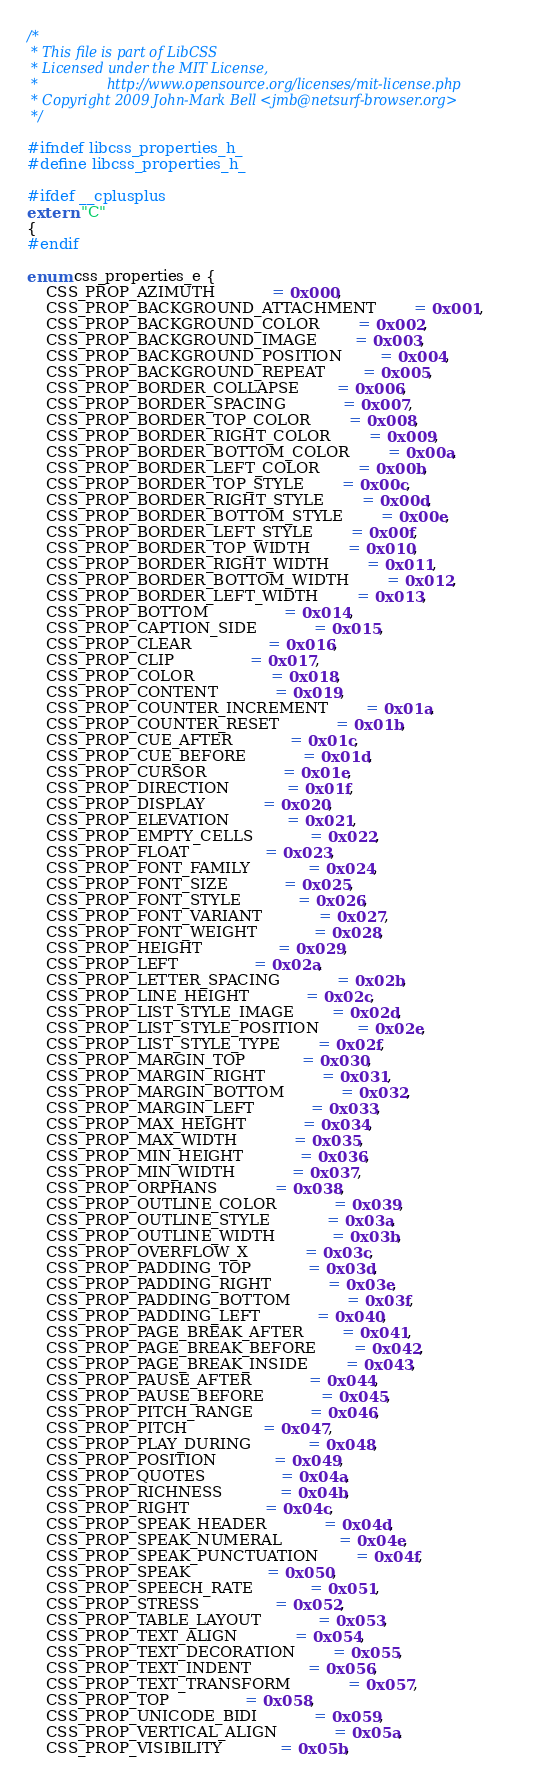Convert code to text. <code><loc_0><loc_0><loc_500><loc_500><_C_>/*
 * This file is part of LibCSS
 * Licensed under the MIT License,
 *                http://www.opensource.org/licenses/mit-license.php
 * Copyright 2009 John-Mark Bell <jmb@netsurf-browser.org>
 */

#ifndef libcss_properties_h_
#define libcss_properties_h_

#ifdef __cplusplus
extern "C"
{
#endif

enum css_properties_e {
	CSS_PROP_AZIMUTH			= 0x000,
	CSS_PROP_BACKGROUND_ATTACHMENT		= 0x001,
	CSS_PROP_BACKGROUND_COLOR		= 0x002,
	CSS_PROP_BACKGROUND_IMAGE		= 0x003,
	CSS_PROP_BACKGROUND_POSITION		= 0x004,
	CSS_PROP_BACKGROUND_REPEAT		= 0x005,
	CSS_PROP_BORDER_COLLAPSE		= 0x006,
	CSS_PROP_BORDER_SPACING			= 0x007,
	CSS_PROP_BORDER_TOP_COLOR		= 0x008,
	CSS_PROP_BORDER_RIGHT_COLOR		= 0x009,
	CSS_PROP_BORDER_BOTTOM_COLOR		= 0x00a,
	CSS_PROP_BORDER_LEFT_COLOR		= 0x00b,
	CSS_PROP_BORDER_TOP_STYLE		= 0x00c,
	CSS_PROP_BORDER_RIGHT_STYLE		= 0x00d,
	CSS_PROP_BORDER_BOTTOM_STYLE		= 0x00e,
	CSS_PROP_BORDER_LEFT_STYLE		= 0x00f,
	CSS_PROP_BORDER_TOP_WIDTH		= 0x010,
	CSS_PROP_BORDER_RIGHT_WIDTH		= 0x011,
	CSS_PROP_BORDER_BOTTOM_WIDTH		= 0x012,
	CSS_PROP_BORDER_LEFT_WIDTH		= 0x013,
	CSS_PROP_BOTTOM				= 0x014,
	CSS_PROP_CAPTION_SIDE			= 0x015,
	CSS_PROP_CLEAR				= 0x016,
	CSS_PROP_CLIP				= 0x017,
	CSS_PROP_COLOR				= 0x018,
	CSS_PROP_CONTENT			= 0x019,
	CSS_PROP_COUNTER_INCREMENT		= 0x01a,
	CSS_PROP_COUNTER_RESET			= 0x01b,
	CSS_PROP_CUE_AFTER			= 0x01c,
	CSS_PROP_CUE_BEFORE			= 0x01d,
	CSS_PROP_CURSOR				= 0x01e,
	CSS_PROP_DIRECTION			= 0x01f,
	CSS_PROP_DISPLAY			= 0x020,
	CSS_PROP_ELEVATION			= 0x021,
	CSS_PROP_EMPTY_CELLS			= 0x022,
	CSS_PROP_FLOAT				= 0x023,
	CSS_PROP_FONT_FAMILY			= 0x024,
	CSS_PROP_FONT_SIZE			= 0x025,
	CSS_PROP_FONT_STYLE			= 0x026,
	CSS_PROP_FONT_VARIANT			= 0x027,
	CSS_PROP_FONT_WEIGHT			= 0x028,
	CSS_PROP_HEIGHT				= 0x029,
	CSS_PROP_LEFT				= 0x02a,
	CSS_PROP_LETTER_SPACING			= 0x02b,
	CSS_PROP_LINE_HEIGHT			= 0x02c,
	CSS_PROP_LIST_STYLE_IMAGE		= 0x02d,
	CSS_PROP_LIST_STYLE_POSITION		= 0x02e,
	CSS_PROP_LIST_STYLE_TYPE		= 0x02f,
	CSS_PROP_MARGIN_TOP			= 0x030,
	CSS_PROP_MARGIN_RIGHT			= 0x031,
	CSS_PROP_MARGIN_BOTTOM			= 0x032,
	CSS_PROP_MARGIN_LEFT			= 0x033,
	CSS_PROP_MAX_HEIGHT			= 0x034,
	CSS_PROP_MAX_WIDTH			= 0x035,
	CSS_PROP_MIN_HEIGHT			= 0x036,
	CSS_PROP_MIN_WIDTH			= 0x037,
	CSS_PROP_ORPHANS			= 0x038,
	CSS_PROP_OUTLINE_COLOR			= 0x039,
	CSS_PROP_OUTLINE_STYLE			= 0x03a,
	CSS_PROP_OUTLINE_WIDTH			= 0x03b,
	CSS_PROP_OVERFLOW_X			= 0x03c,
	CSS_PROP_PADDING_TOP			= 0x03d,
	CSS_PROP_PADDING_RIGHT			= 0x03e,
	CSS_PROP_PADDING_BOTTOM			= 0x03f,
	CSS_PROP_PADDING_LEFT			= 0x040,
	CSS_PROP_PAGE_BREAK_AFTER		= 0x041,
	CSS_PROP_PAGE_BREAK_BEFORE		= 0x042,
	CSS_PROP_PAGE_BREAK_INSIDE		= 0x043,
	CSS_PROP_PAUSE_AFTER			= 0x044,
	CSS_PROP_PAUSE_BEFORE			= 0x045,
	CSS_PROP_PITCH_RANGE			= 0x046,
	CSS_PROP_PITCH				= 0x047,
	CSS_PROP_PLAY_DURING			= 0x048,
	CSS_PROP_POSITION			= 0x049,
	CSS_PROP_QUOTES				= 0x04a,
	CSS_PROP_RICHNESS			= 0x04b,
	CSS_PROP_RIGHT				= 0x04c,
	CSS_PROP_SPEAK_HEADER			= 0x04d,
	CSS_PROP_SPEAK_NUMERAL			= 0x04e,
	CSS_PROP_SPEAK_PUNCTUATION		= 0x04f,
	CSS_PROP_SPEAK				= 0x050,
	CSS_PROP_SPEECH_RATE			= 0x051,
	CSS_PROP_STRESS				= 0x052,
	CSS_PROP_TABLE_LAYOUT			= 0x053,
	CSS_PROP_TEXT_ALIGN			= 0x054,
	CSS_PROP_TEXT_DECORATION		= 0x055,
	CSS_PROP_TEXT_INDENT			= 0x056,
	CSS_PROP_TEXT_TRANSFORM			= 0x057,
	CSS_PROP_TOP				= 0x058,
	CSS_PROP_UNICODE_BIDI			= 0x059,
	CSS_PROP_VERTICAL_ALIGN			= 0x05a,
	CSS_PROP_VISIBILITY			= 0x05b,</code> 